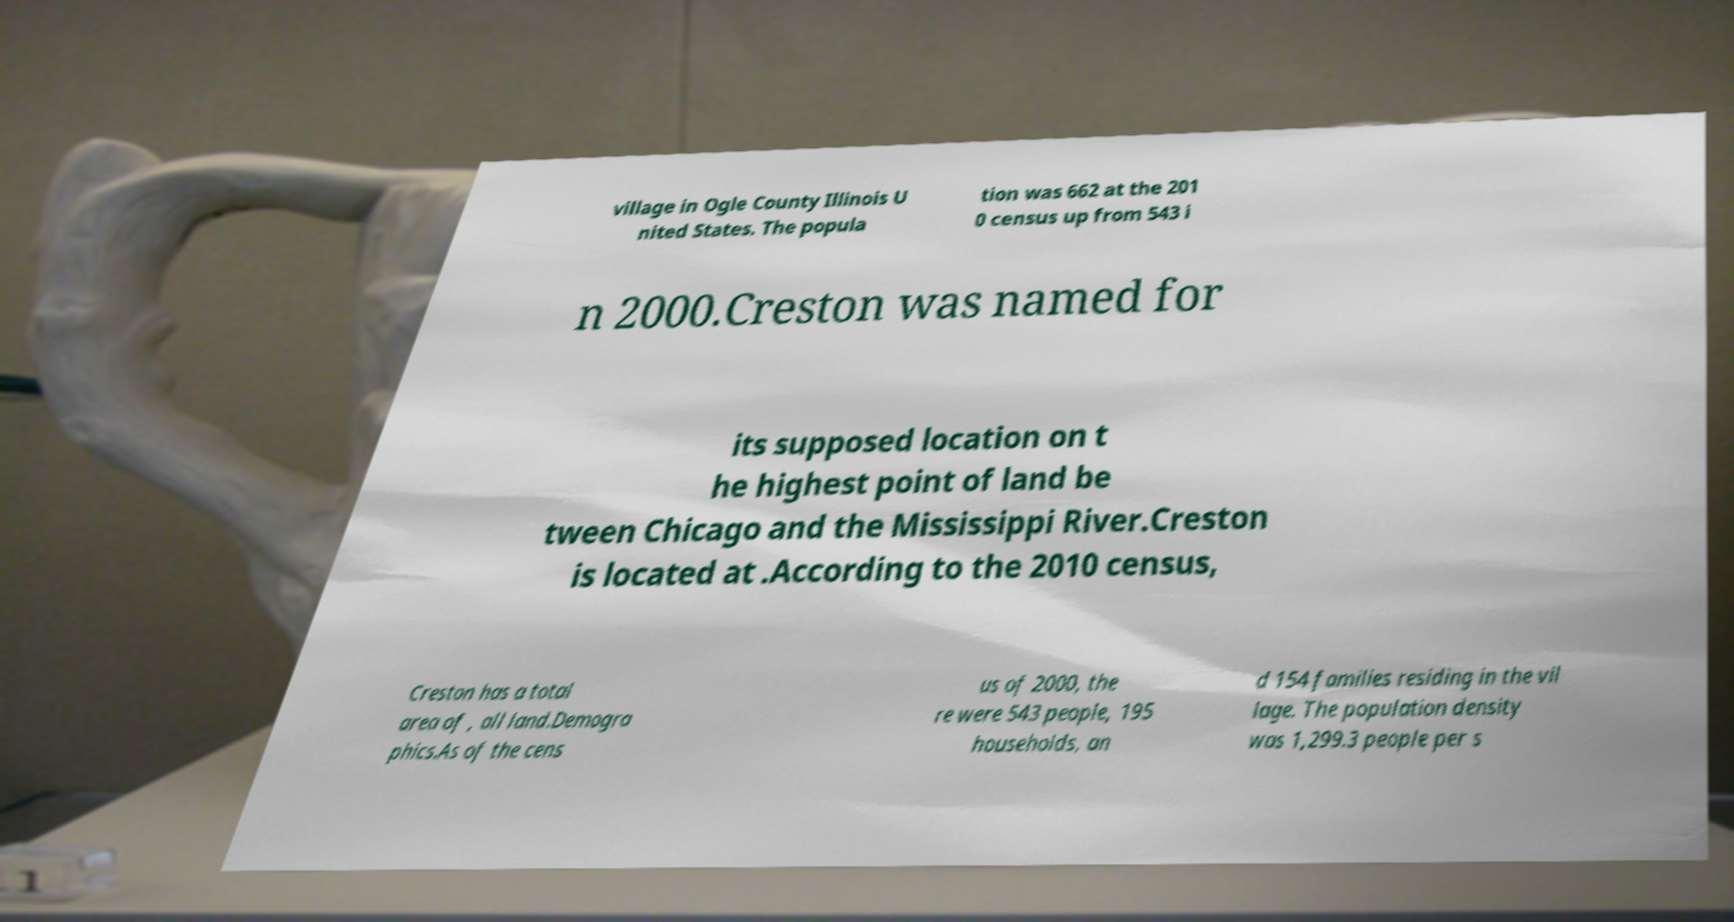Please identify and transcribe the text found in this image. village in Ogle County Illinois U nited States. The popula tion was 662 at the 201 0 census up from 543 i n 2000.Creston was named for its supposed location on t he highest point of land be tween Chicago and the Mississippi River.Creston is located at .According to the 2010 census, Creston has a total area of , all land.Demogra phics.As of the cens us of 2000, the re were 543 people, 195 households, an d 154 families residing in the vil lage. The population density was 1,299.3 people per s 